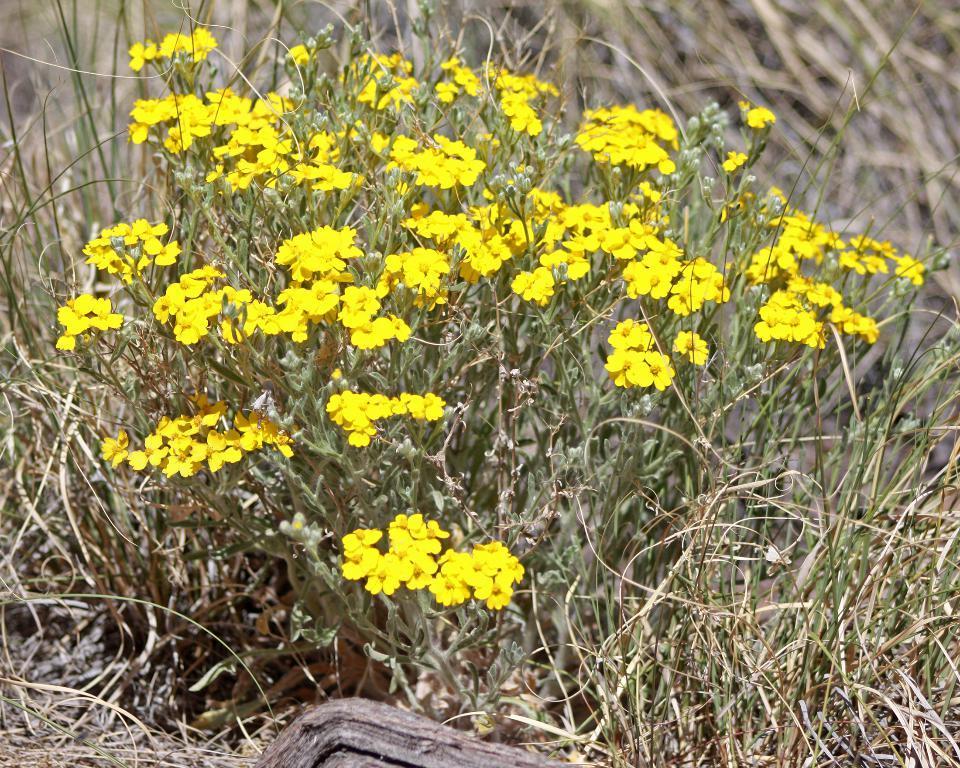Can you describe this image briefly? In this picture we can see a few yellow flowers and some grass on the ground. Background is blurry. 